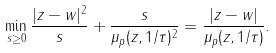Convert formula to latex. <formula><loc_0><loc_0><loc_500><loc_500>\min _ { s \geq 0 } \frac { | z - w | ^ { 2 } } s + \frac { s } { \mu _ { p } ( z , 1 / \tau ) ^ { 2 } } = \frac { | z - w | } { \mu _ { p } ( z , 1 / \tau ) } .</formula> 